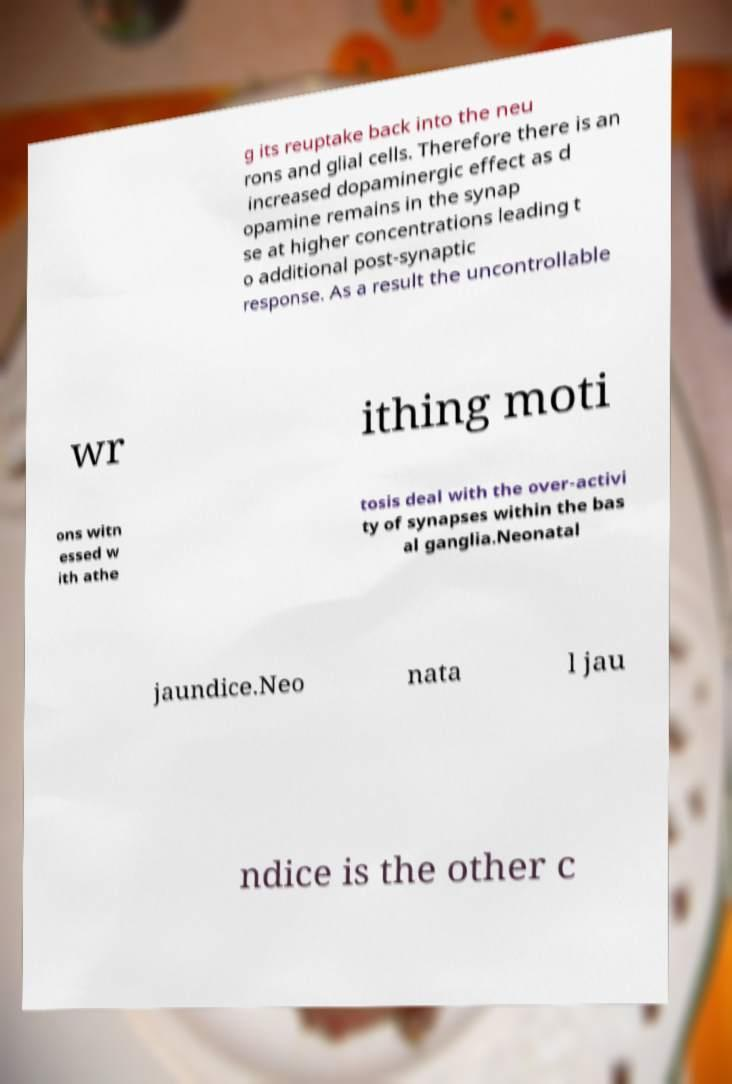For documentation purposes, I need the text within this image transcribed. Could you provide that? g its reuptake back into the neu rons and glial cells. Therefore there is an increased dopaminergic effect as d opamine remains in the synap se at higher concentrations leading t o additional post-synaptic response. As a result the uncontrollable wr ithing moti ons witn essed w ith athe tosis deal with the over-activi ty of synapses within the bas al ganglia.Neonatal jaundice.Neo nata l jau ndice is the other c 